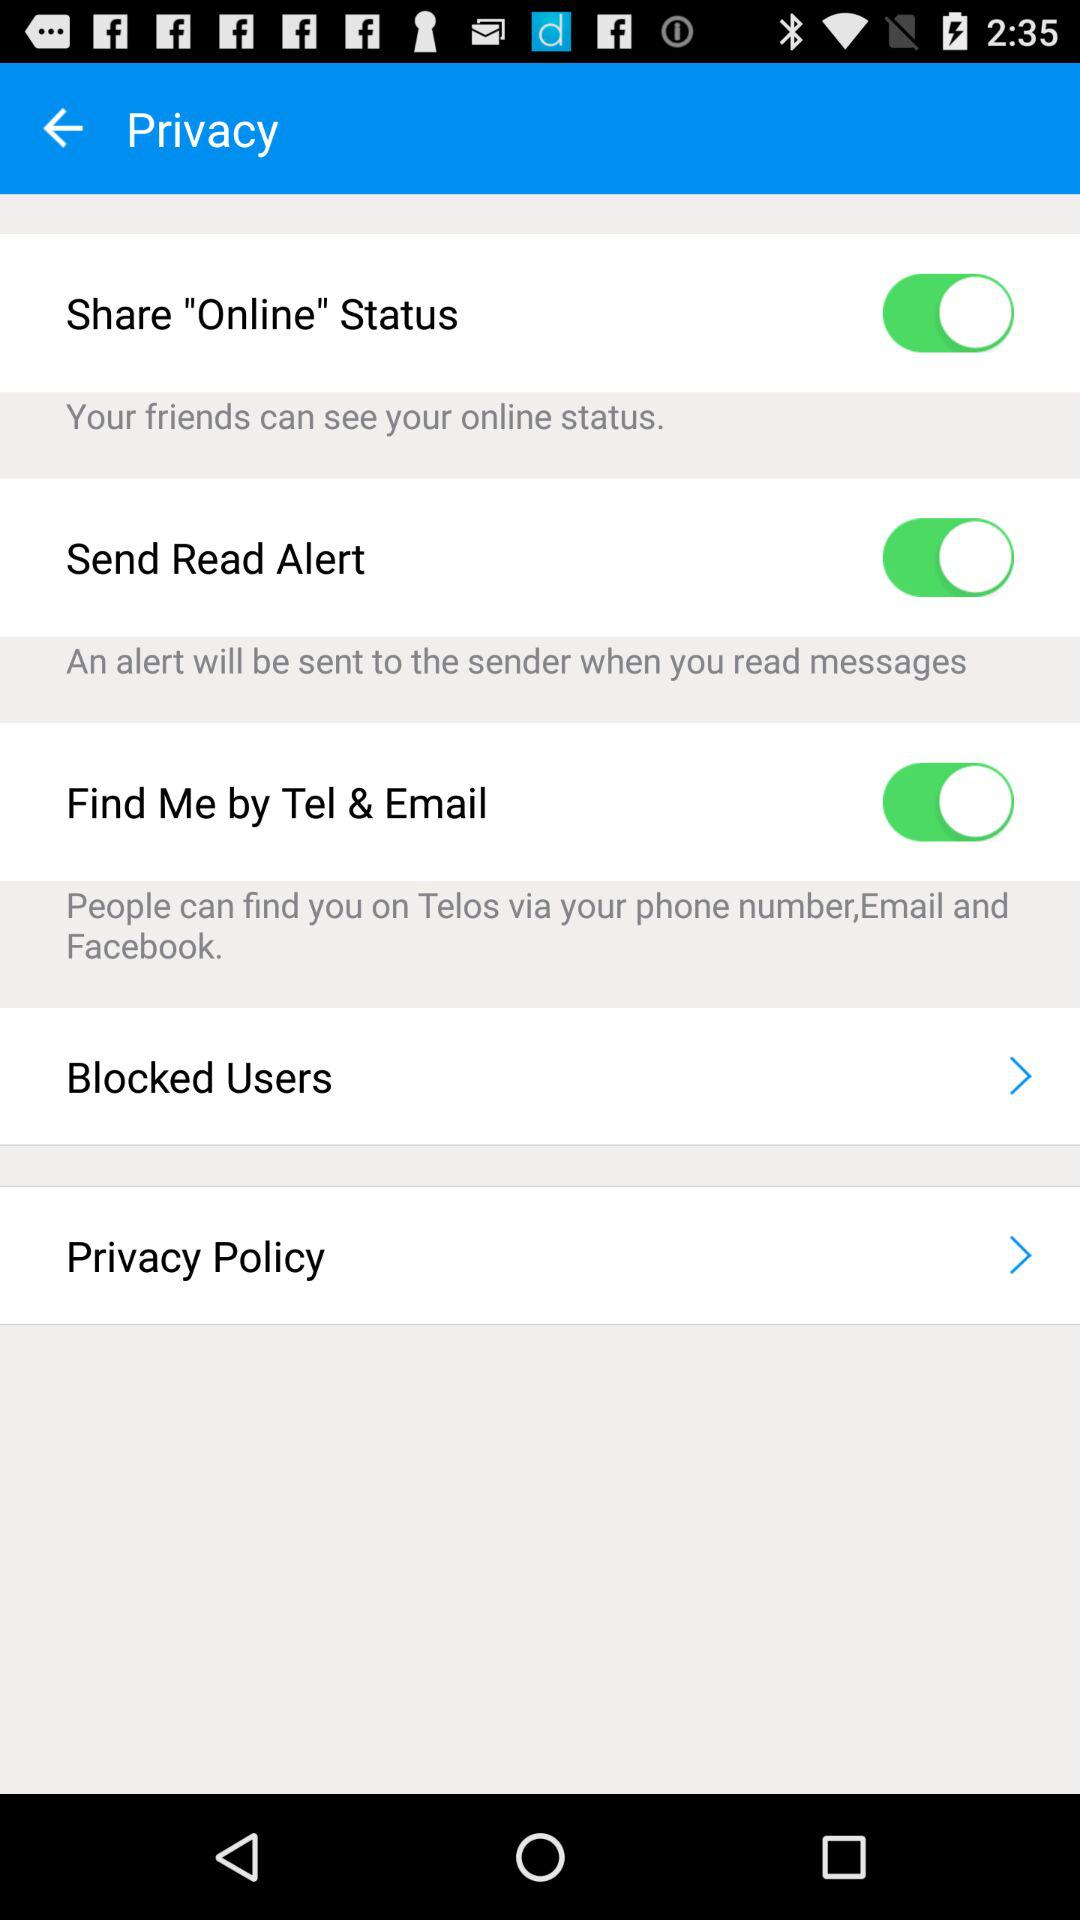Has the user agreed to the privacy policy?
When the provided information is insufficient, respond with <no answer>. <no answer> 